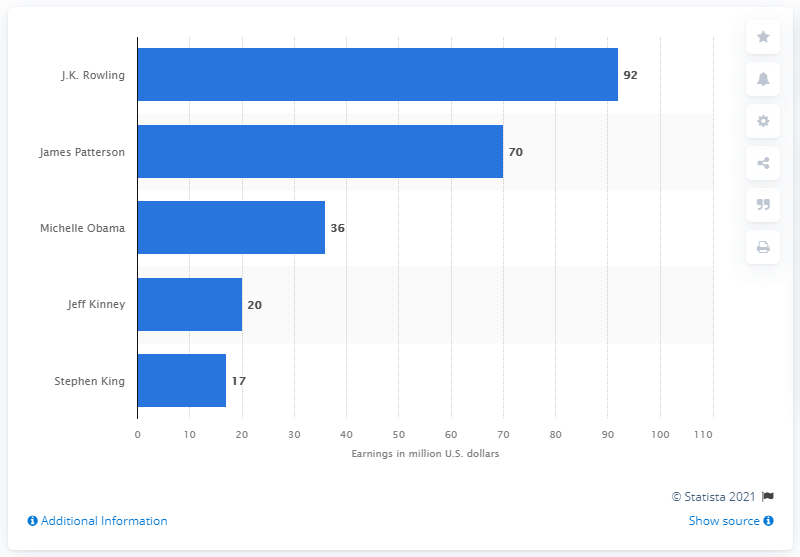Outline some significant characteristics in this image. J.K. Rowling earned approximately $92 million in the United States in 2019. J.K. Rowling, a renowned author, was accompanied by Stephen King. 